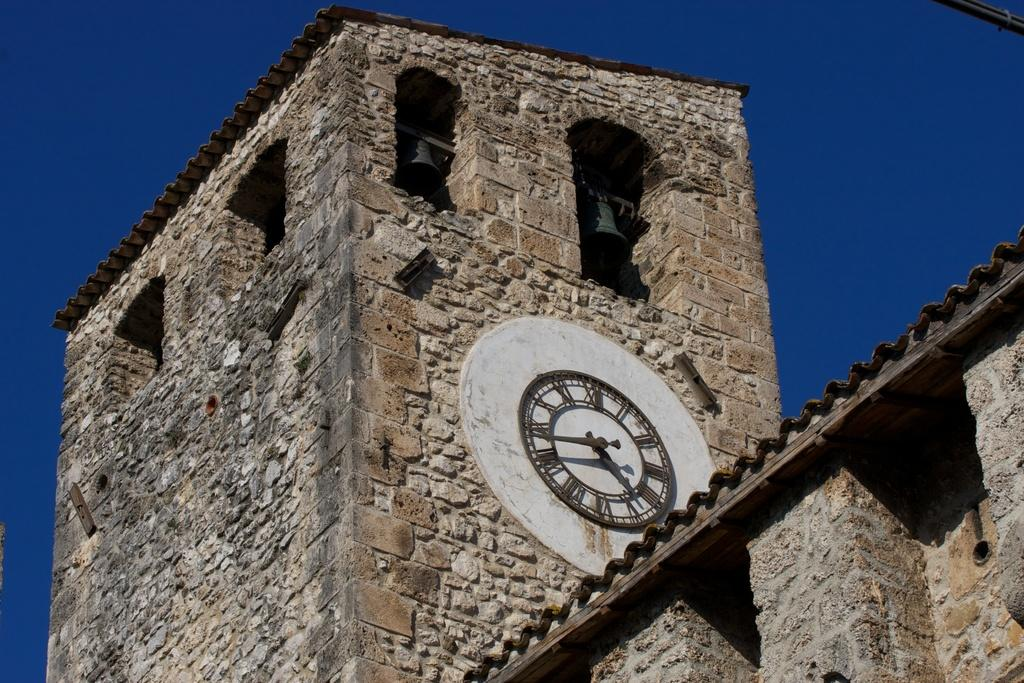What type of structure is present in the image? There is a building in the image. Can you describe any specific features of the building? There is a clock on a wall in the image. What can be seen in the background of the image? The sky is visible in the image. What is the color of the sky in the image? The color of the sky is blue. How many ladybugs can be seen crawling on the clock in the image? There are no ladybugs present in the image; the clock is the only item mentioned on the wall. 